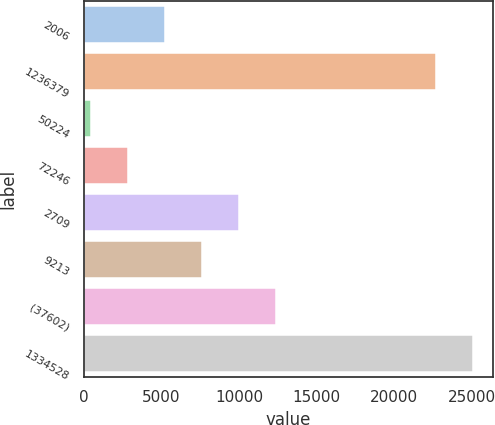<chart> <loc_0><loc_0><loc_500><loc_500><bar_chart><fcel>2006<fcel>1236379<fcel>50224<fcel>72246<fcel>2709<fcel>9213<fcel>(37602)<fcel>1334528<nl><fcel>5215.8<fcel>22705<fcel>453<fcel>2834.4<fcel>9978.6<fcel>7597.2<fcel>12360<fcel>25086.4<nl></chart> 